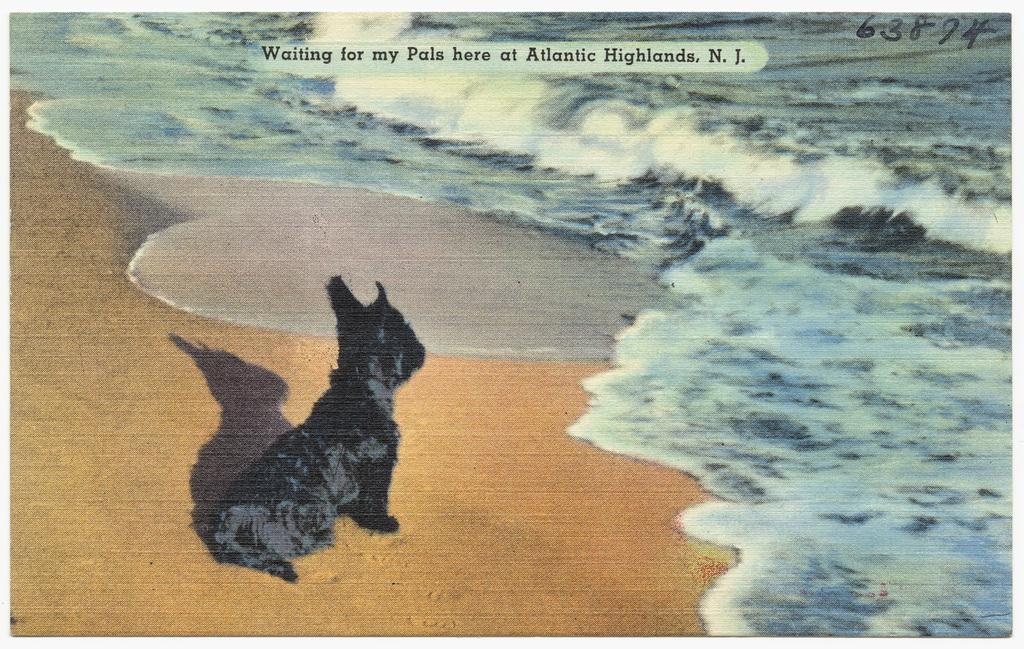What animal can be seen on the left side of the image? There is a dog on the left side of the image. What natural element is present on the right side of the image? Water is present on the right side of the image. What type of surface is visible at the bottom of the image? Soil is visible at the bottom of the image. Where is the scarecrow located in the image? There is no scarecrow present in the image. How does the dog maintain its balance in the image? The dog's balance is not a focus of the image, and there is no information provided about its balance. 